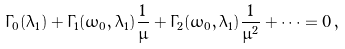Convert formula to latex. <formula><loc_0><loc_0><loc_500><loc_500>\Gamma _ { 0 } ( \lambda _ { 1 } ) + \Gamma _ { 1 } ( \omega _ { 0 } , \lambda _ { 1 } ) \frac { 1 } { \mu } + \Gamma _ { 2 } ( \omega _ { 0 } , \lambda _ { 1 } ) \frac { 1 } { \mu ^ { 2 } } + \dots = 0 \, ,</formula> 